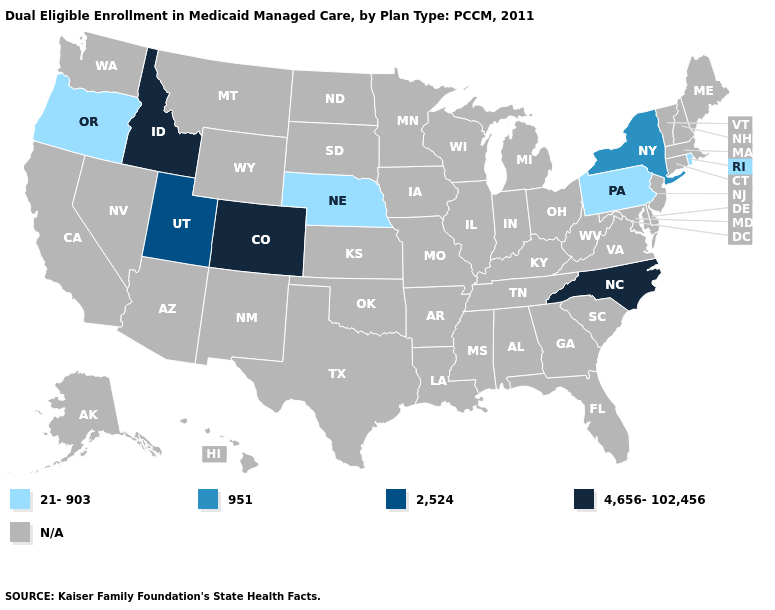Name the states that have a value in the range 2,524?
Give a very brief answer. Utah. Is the legend a continuous bar?
Short answer required. No. Does New York have the highest value in the Northeast?
Write a very short answer. Yes. What is the lowest value in the West?
Write a very short answer. 21-903. Among the states that border Oklahoma , which have the highest value?
Keep it brief. Colorado. Name the states that have a value in the range 4,656-102,456?
Concise answer only. Colorado, Idaho, North Carolina. What is the highest value in the USA?
Give a very brief answer. 4,656-102,456. What is the value of Florida?
Keep it brief. N/A. Which states hav the highest value in the South?
Keep it brief. North Carolina. 